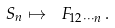<formula> <loc_0><loc_0><loc_500><loc_500>S _ { n } \mapsto \ F _ { 1 2 \cdots n } \, .</formula> 